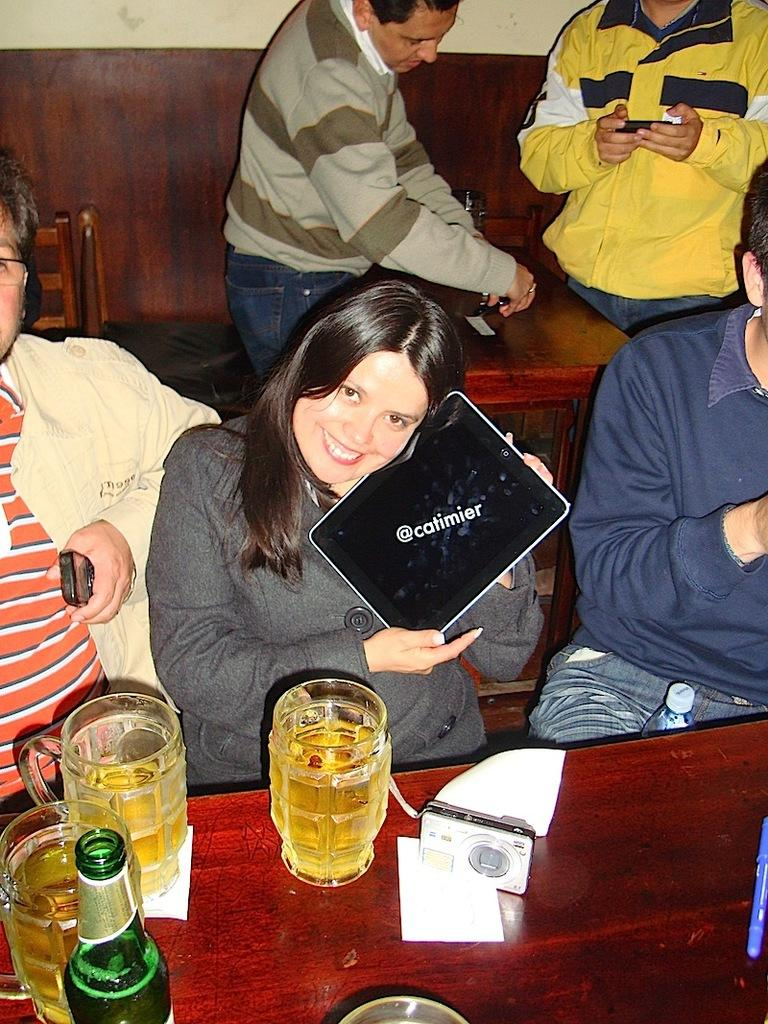How many people are sitting in the image? There are three people sitting in the image. What are the sitting people doing in the image? The sitting people are in front of a table. What can be seen on the table in the image? There are glasses with beer and a bottle on the table. Are there any other people visible in the image? Yes, there are two other people standing behind the sitting people. What type of cattle can be seen grazing on the road in the image? There is no road or cattle present in the image. Is there a giraffe visible in the image? No, there is no giraffe present in the image. 